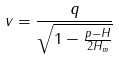<formula> <loc_0><loc_0><loc_500><loc_500>v = \frac { q } { \sqrt { 1 - \frac { p - H } { 2 H _ { m } } } }</formula> 